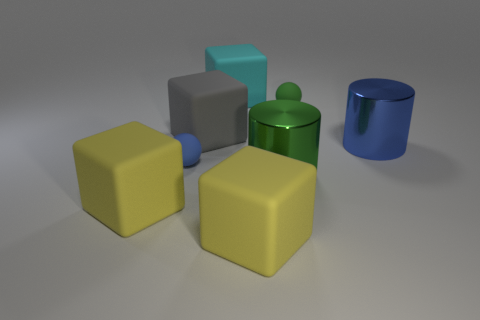There is a big green object that is the same shape as the blue metal object; what material is it?
Offer a very short reply. Metal. Does the cube that is behind the green matte object have the same size as the small blue sphere?
Your response must be concise. No. What is the big object that is both behind the blue matte ball and on the right side of the large cyan matte object made of?
Offer a very short reply. Metal. There is a object that is both on the right side of the big green metallic cylinder and on the left side of the large blue shiny cylinder; what is its size?
Provide a succinct answer. Small. There is a matte object that is to the right of the large cyan rubber object and behind the gray cube; what is its color?
Make the answer very short. Green. There is a tiny thing on the right side of the blue matte sphere; what is it made of?
Keep it short and to the point. Rubber. The green metal cylinder is what size?
Offer a very short reply. Large. How many cyan things are large cylinders or small rubber spheres?
Offer a very short reply. 0. There is a ball that is in front of the sphere on the right side of the large green thing; what is its size?
Give a very brief answer. Small. What number of other objects are there of the same material as the blue sphere?
Provide a short and direct response. 5. 